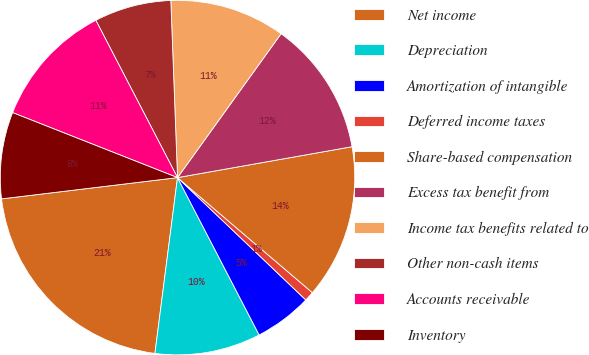Convert chart. <chart><loc_0><loc_0><loc_500><loc_500><pie_chart><fcel>Net income<fcel>Depreciation<fcel>Amortization of intangible<fcel>Deferred income taxes<fcel>Share-based compensation<fcel>Excess tax benefit from<fcel>Income tax benefits related to<fcel>Other non-cash items<fcel>Accounts receivable<fcel>Inventory<nl><fcel>21.05%<fcel>9.65%<fcel>5.26%<fcel>0.88%<fcel>14.03%<fcel>12.28%<fcel>10.53%<fcel>7.02%<fcel>11.4%<fcel>7.89%<nl></chart> 